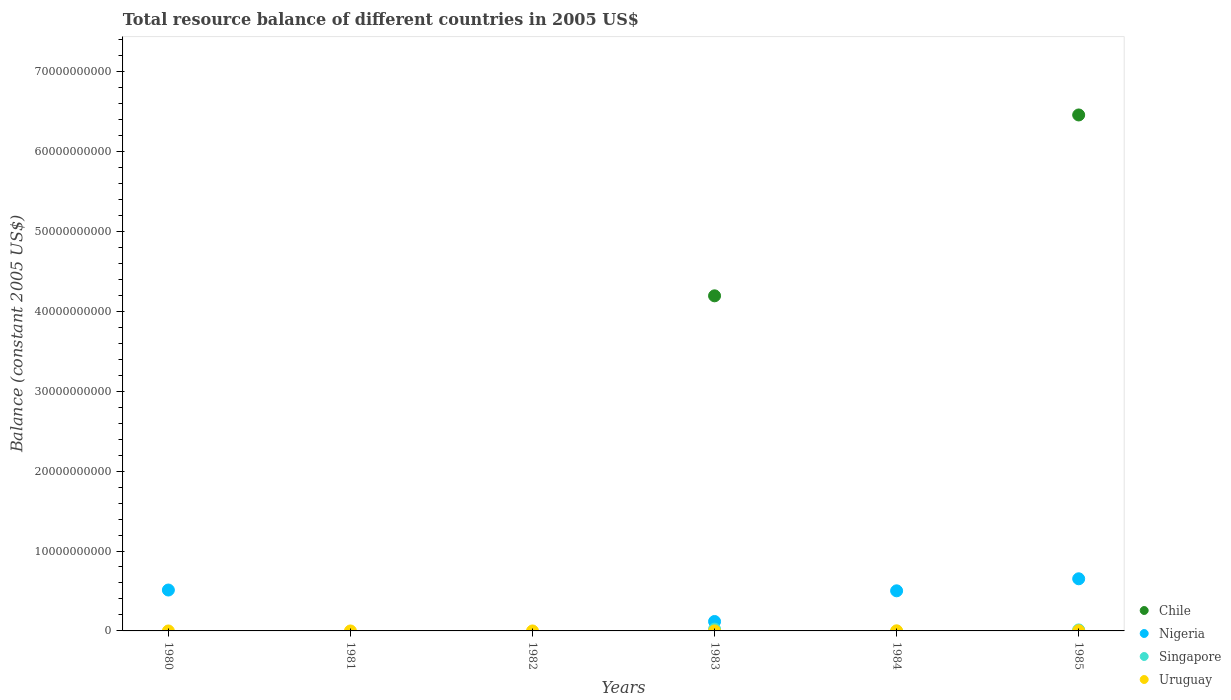How many different coloured dotlines are there?
Ensure brevity in your answer.  4. Is the number of dotlines equal to the number of legend labels?
Ensure brevity in your answer.  No. What is the total resource balance in Singapore in 1982?
Offer a terse response. 0. Across all years, what is the maximum total resource balance in Singapore?
Your answer should be compact. 2.22e+08. Across all years, what is the minimum total resource balance in Chile?
Your answer should be very brief. 0. What is the total total resource balance in Uruguay in the graph?
Provide a short and direct response. 4.48e+07. What is the difference between the total resource balance in Nigeria in 1980 and that in 1984?
Offer a very short reply. 9.83e+07. What is the difference between the total resource balance in Nigeria in 1984 and the total resource balance in Uruguay in 1985?
Give a very brief answer. 4.99e+09. What is the average total resource balance in Chile per year?
Your answer should be very brief. 1.77e+1. In the year 1983, what is the difference between the total resource balance in Chile and total resource balance in Nigeria?
Offer a very short reply. 4.08e+1. In how many years, is the total resource balance in Nigeria greater than 8000000000 US$?
Your answer should be very brief. 0. What is the ratio of the total resource balance in Uruguay in 1984 to that in 1985?
Give a very brief answer. 0.52. What is the difference between the highest and the second highest total resource balance in Uruguay?
Offer a very short reply. 1.30e+07. What is the difference between the highest and the lowest total resource balance in Uruguay?
Your answer should be compact. 2.71e+07. Is the total resource balance in Singapore strictly greater than the total resource balance in Nigeria over the years?
Give a very brief answer. No. How many dotlines are there?
Keep it short and to the point. 4. Does the graph contain any zero values?
Your response must be concise. Yes. Does the graph contain grids?
Your response must be concise. No. Where does the legend appear in the graph?
Give a very brief answer. Bottom right. How many legend labels are there?
Offer a terse response. 4. What is the title of the graph?
Your response must be concise. Total resource balance of different countries in 2005 US$. What is the label or title of the Y-axis?
Give a very brief answer. Balance (constant 2005 US$). What is the Balance (constant 2005 US$) in Chile in 1980?
Provide a short and direct response. 0. What is the Balance (constant 2005 US$) in Nigeria in 1980?
Your answer should be compact. 5.12e+09. What is the Balance (constant 2005 US$) of Singapore in 1980?
Give a very brief answer. 0. What is the Balance (constant 2005 US$) of Singapore in 1981?
Provide a short and direct response. 0. What is the Balance (constant 2005 US$) of Uruguay in 1981?
Provide a succinct answer. 0. What is the Balance (constant 2005 US$) in Chile in 1982?
Your response must be concise. 0. What is the Balance (constant 2005 US$) in Uruguay in 1982?
Your answer should be compact. 0. What is the Balance (constant 2005 US$) in Chile in 1983?
Offer a terse response. 4.19e+1. What is the Balance (constant 2005 US$) in Nigeria in 1983?
Your answer should be very brief. 1.18e+09. What is the Balance (constant 2005 US$) in Singapore in 1983?
Make the answer very short. 2.22e+08. What is the Balance (constant 2005 US$) in Uruguay in 1983?
Make the answer very short. 3.66e+06. What is the Balance (constant 2005 US$) in Nigeria in 1984?
Offer a very short reply. 5.02e+09. What is the Balance (constant 2005 US$) in Uruguay in 1984?
Give a very brief answer. 1.41e+07. What is the Balance (constant 2005 US$) in Chile in 1985?
Your response must be concise. 6.46e+1. What is the Balance (constant 2005 US$) of Nigeria in 1985?
Make the answer very short. 6.52e+09. What is the Balance (constant 2005 US$) of Singapore in 1985?
Provide a succinct answer. 1.22e+08. What is the Balance (constant 2005 US$) of Uruguay in 1985?
Give a very brief answer. 2.71e+07. Across all years, what is the maximum Balance (constant 2005 US$) of Chile?
Provide a short and direct response. 6.46e+1. Across all years, what is the maximum Balance (constant 2005 US$) in Nigeria?
Make the answer very short. 6.52e+09. Across all years, what is the maximum Balance (constant 2005 US$) in Singapore?
Keep it short and to the point. 2.22e+08. Across all years, what is the maximum Balance (constant 2005 US$) in Uruguay?
Keep it short and to the point. 2.71e+07. Across all years, what is the minimum Balance (constant 2005 US$) of Chile?
Keep it short and to the point. 0. Across all years, what is the minimum Balance (constant 2005 US$) of Singapore?
Give a very brief answer. 0. Across all years, what is the minimum Balance (constant 2005 US$) of Uruguay?
Ensure brevity in your answer.  0. What is the total Balance (constant 2005 US$) of Chile in the graph?
Offer a terse response. 1.06e+11. What is the total Balance (constant 2005 US$) of Nigeria in the graph?
Your response must be concise. 1.78e+1. What is the total Balance (constant 2005 US$) of Singapore in the graph?
Provide a short and direct response. 3.45e+08. What is the total Balance (constant 2005 US$) of Uruguay in the graph?
Your response must be concise. 4.48e+07. What is the difference between the Balance (constant 2005 US$) in Nigeria in 1980 and that in 1983?
Your response must be concise. 3.94e+09. What is the difference between the Balance (constant 2005 US$) of Nigeria in 1980 and that in 1984?
Make the answer very short. 9.83e+07. What is the difference between the Balance (constant 2005 US$) in Nigeria in 1980 and that in 1985?
Provide a succinct answer. -1.41e+09. What is the difference between the Balance (constant 2005 US$) of Nigeria in 1983 and that in 1984?
Make the answer very short. -3.84e+09. What is the difference between the Balance (constant 2005 US$) in Uruguay in 1983 and that in 1984?
Keep it short and to the point. -1.05e+07. What is the difference between the Balance (constant 2005 US$) in Chile in 1983 and that in 1985?
Offer a terse response. -2.26e+1. What is the difference between the Balance (constant 2005 US$) of Nigeria in 1983 and that in 1985?
Make the answer very short. -5.34e+09. What is the difference between the Balance (constant 2005 US$) of Singapore in 1983 and that in 1985?
Provide a succinct answer. 9.98e+07. What is the difference between the Balance (constant 2005 US$) in Uruguay in 1983 and that in 1985?
Make the answer very short. -2.34e+07. What is the difference between the Balance (constant 2005 US$) of Nigeria in 1984 and that in 1985?
Make the answer very short. -1.50e+09. What is the difference between the Balance (constant 2005 US$) of Uruguay in 1984 and that in 1985?
Provide a succinct answer. -1.30e+07. What is the difference between the Balance (constant 2005 US$) in Nigeria in 1980 and the Balance (constant 2005 US$) in Singapore in 1983?
Your answer should be compact. 4.89e+09. What is the difference between the Balance (constant 2005 US$) of Nigeria in 1980 and the Balance (constant 2005 US$) of Uruguay in 1983?
Ensure brevity in your answer.  5.11e+09. What is the difference between the Balance (constant 2005 US$) in Nigeria in 1980 and the Balance (constant 2005 US$) in Uruguay in 1984?
Ensure brevity in your answer.  5.10e+09. What is the difference between the Balance (constant 2005 US$) in Nigeria in 1980 and the Balance (constant 2005 US$) in Singapore in 1985?
Offer a terse response. 4.99e+09. What is the difference between the Balance (constant 2005 US$) in Nigeria in 1980 and the Balance (constant 2005 US$) in Uruguay in 1985?
Provide a succinct answer. 5.09e+09. What is the difference between the Balance (constant 2005 US$) of Chile in 1983 and the Balance (constant 2005 US$) of Nigeria in 1984?
Give a very brief answer. 3.69e+1. What is the difference between the Balance (constant 2005 US$) in Chile in 1983 and the Balance (constant 2005 US$) in Uruguay in 1984?
Keep it short and to the point. 4.19e+1. What is the difference between the Balance (constant 2005 US$) of Nigeria in 1983 and the Balance (constant 2005 US$) of Uruguay in 1984?
Keep it short and to the point. 1.17e+09. What is the difference between the Balance (constant 2005 US$) of Singapore in 1983 and the Balance (constant 2005 US$) of Uruguay in 1984?
Offer a very short reply. 2.08e+08. What is the difference between the Balance (constant 2005 US$) in Chile in 1983 and the Balance (constant 2005 US$) in Nigeria in 1985?
Ensure brevity in your answer.  3.54e+1. What is the difference between the Balance (constant 2005 US$) in Chile in 1983 and the Balance (constant 2005 US$) in Singapore in 1985?
Keep it short and to the point. 4.18e+1. What is the difference between the Balance (constant 2005 US$) in Chile in 1983 and the Balance (constant 2005 US$) in Uruguay in 1985?
Make the answer very short. 4.19e+1. What is the difference between the Balance (constant 2005 US$) in Nigeria in 1983 and the Balance (constant 2005 US$) in Singapore in 1985?
Provide a succinct answer. 1.06e+09. What is the difference between the Balance (constant 2005 US$) in Nigeria in 1983 and the Balance (constant 2005 US$) in Uruguay in 1985?
Make the answer very short. 1.15e+09. What is the difference between the Balance (constant 2005 US$) of Singapore in 1983 and the Balance (constant 2005 US$) of Uruguay in 1985?
Give a very brief answer. 1.95e+08. What is the difference between the Balance (constant 2005 US$) of Nigeria in 1984 and the Balance (constant 2005 US$) of Singapore in 1985?
Make the answer very short. 4.90e+09. What is the difference between the Balance (constant 2005 US$) in Nigeria in 1984 and the Balance (constant 2005 US$) in Uruguay in 1985?
Offer a terse response. 4.99e+09. What is the average Balance (constant 2005 US$) of Chile per year?
Your response must be concise. 1.77e+1. What is the average Balance (constant 2005 US$) in Nigeria per year?
Keep it short and to the point. 2.97e+09. What is the average Balance (constant 2005 US$) in Singapore per year?
Your answer should be very brief. 5.75e+07. What is the average Balance (constant 2005 US$) of Uruguay per year?
Your answer should be compact. 7.47e+06. In the year 1983, what is the difference between the Balance (constant 2005 US$) in Chile and Balance (constant 2005 US$) in Nigeria?
Your response must be concise. 4.08e+1. In the year 1983, what is the difference between the Balance (constant 2005 US$) of Chile and Balance (constant 2005 US$) of Singapore?
Your response must be concise. 4.17e+1. In the year 1983, what is the difference between the Balance (constant 2005 US$) in Chile and Balance (constant 2005 US$) in Uruguay?
Offer a very short reply. 4.19e+1. In the year 1983, what is the difference between the Balance (constant 2005 US$) in Nigeria and Balance (constant 2005 US$) in Singapore?
Offer a very short reply. 9.57e+08. In the year 1983, what is the difference between the Balance (constant 2005 US$) of Nigeria and Balance (constant 2005 US$) of Uruguay?
Provide a succinct answer. 1.18e+09. In the year 1983, what is the difference between the Balance (constant 2005 US$) in Singapore and Balance (constant 2005 US$) in Uruguay?
Provide a succinct answer. 2.19e+08. In the year 1984, what is the difference between the Balance (constant 2005 US$) of Nigeria and Balance (constant 2005 US$) of Uruguay?
Offer a very short reply. 5.00e+09. In the year 1985, what is the difference between the Balance (constant 2005 US$) in Chile and Balance (constant 2005 US$) in Nigeria?
Give a very brief answer. 5.80e+1. In the year 1985, what is the difference between the Balance (constant 2005 US$) in Chile and Balance (constant 2005 US$) in Singapore?
Give a very brief answer. 6.44e+1. In the year 1985, what is the difference between the Balance (constant 2005 US$) in Chile and Balance (constant 2005 US$) in Uruguay?
Your response must be concise. 6.45e+1. In the year 1985, what is the difference between the Balance (constant 2005 US$) in Nigeria and Balance (constant 2005 US$) in Singapore?
Offer a terse response. 6.40e+09. In the year 1985, what is the difference between the Balance (constant 2005 US$) in Nigeria and Balance (constant 2005 US$) in Uruguay?
Ensure brevity in your answer.  6.50e+09. In the year 1985, what is the difference between the Balance (constant 2005 US$) in Singapore and Balance (constant 2005 US$) in Uruguay?
Give a very brief answer. 9.54e+07. What is the ratio of the Balance (constant 2005 US$) in Nigeria in 1980 to that in 1983?
Make the answer very short. 4.34. What is the ratio of the Balance (constant 2005 US$) in Nigeria in 1980 to that in 1984?
Provide a succinct answer. 1.02. What is the ratio of the Balance (constant 2005 US$) in Nigeria in 1980 to that in 1985?
Give a very brief answer. 0.78. What is the ratio of the Balance (constant 2005 US$) in Nigeria in 1983 to that in 1984?
Offer a very short reply. 0.23. What is the ratio of the Balance (constant 2005 US$) of Uruguay in 1983 to that in 1984?
Provide a short and direct response. 0.26. What is the ratio of the Balance (constant 2005 US$) of Chile in 1983 to that in 1985?
Make the answer very short. 0.65. What is the ratio of the Balance (constant 2005 US$) in Nigeria in 1983 to that in 1985?
Offer a terse response. 0.18. What is the ratio of the Balance (constant 2005 US$) in Singapore in 1983 to that in 1985?
Offer a terse response. 1.81. What is the ratio of the Balance (constant 2005 US$) in Uruguay in 1983 to that in 1985?
Your response must be concise. 0.14. What is the ratio of the Balance (constant 2005 US$) of Nigeria in 1984 to that in 1985?
Offer a terse response. 0.77. What is the ratio of the Balance (constant 2005 US$) in Uruguay in 1984 to that in 1985?
Provide a short and direct response. 0.52. What is the difference between the highest and the second highest Balance (constant 2005 US$) of Nigeria?
Provide a short and direct response. 1.41e+09. What is the difference between the highest and the second highest Balance (constant 2005 US$) of Uruguay?
Offer a very short reply. 1.30e+07. What is the difference between the highest and the lowest Balance (constant 2005 US$) of Chile?
Your answer should be very brief. 6.46e+1. What is the difference between the highest and the lowest Balance (constant 2005 US$) of Nigeria?
Give a very brief answer. 6.52e+09. What is the difference between the highest and the lowest Balance (constant 2005 US$) of Singapore?
Your answer should be compact. 2.22e+08. What is the difference between the highest and the lowest Balance (constant 2005 US$) in Uruguay?
Give a very brief answer. 2.71e+07. 